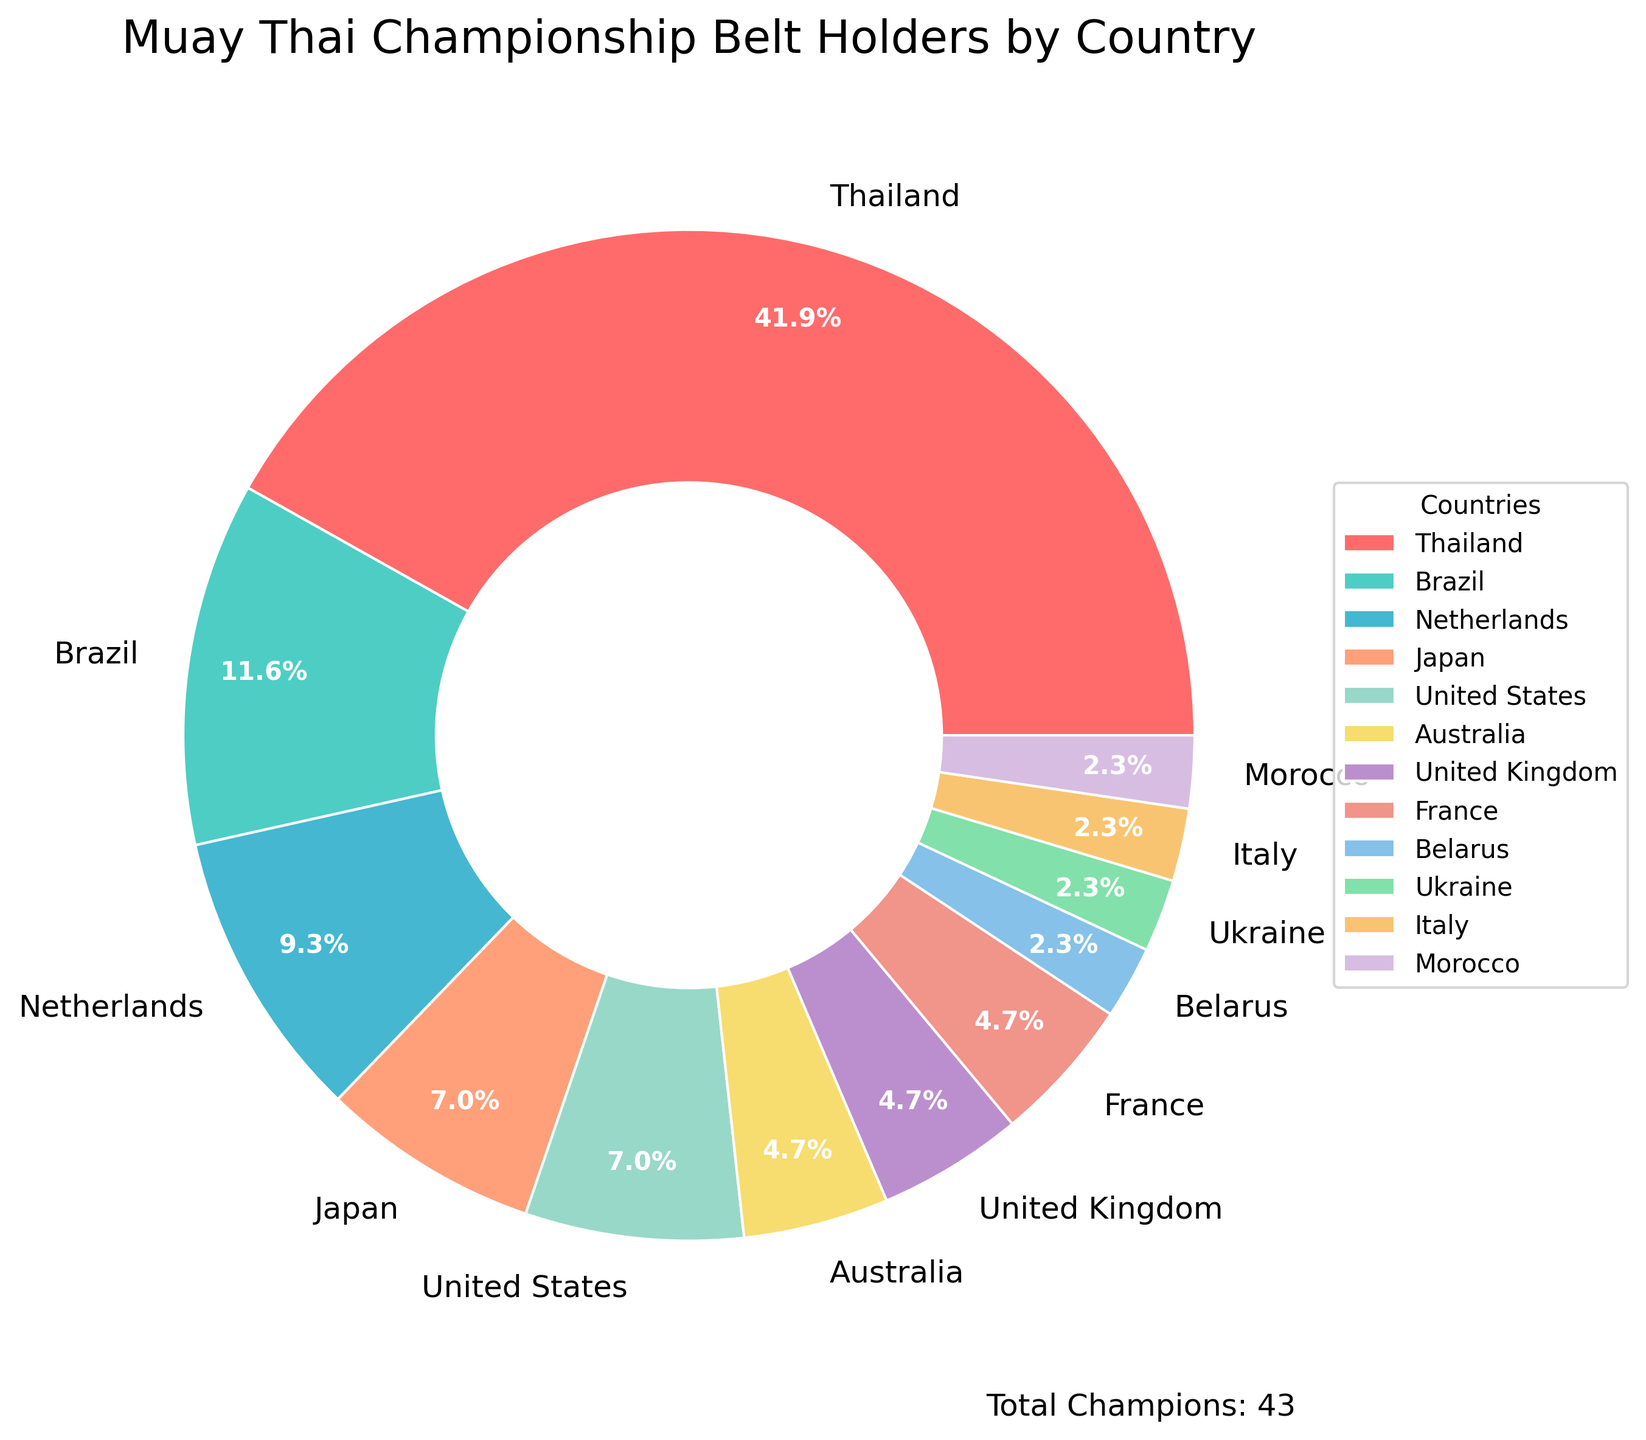Which country has the most Muay Thai championship belt holders? The figure shows that Thailand has the largest portion of the pie chart. By checking the labels, it is clear that Thailand has the highest number of champions.
Answer: Thailand How many total Muay Thai champions do the top three countries have combined? The top three countries by number of champions are Thailand (18), Brazil (5), and the Netherlands (4). Summing these values gives the total: 18 + 5 + 4 = 27
Answer: 27 Which countries have an equal number of Muay Thai champions? According to the figure, Japan and the United States both have 3 champions. Additionally, Australia, United Kingdom, and France each have 2 champions.
Answer: Japan and the United States; Australia, United Kingdom, and France What percentage of Muay Thai champions come from Thailand? The figure shows that Thailand holds 18 champions out of a total sum of 18 + 5 + 4 + 3 + 3 + 2 + 2 + 2 + 1 + 1 + 1 + 1 = 43 champions. The percentage is (18/43) * 100% ≈ 41.9%.
Answer: 41.9% How many countries have only one Muay Thai champion? By looking at the segments with smaller percentages and labels of "1", there are four countries: Belarus, Ukraine, Italy, and Morocco.
Answer: 4 Which country has fewer Muay Thai champions, France or the Netherlands? Referring to the pie chart, the Netherlands has 4 champions, whereas France has 2 champions. Therefore, France has fewer champions.
Answer: France If we grouped all countries that have 3 or fewer champions together, what percentage of the total would they represent? The countries with 3 or fewer champions are Brazil (5), Japan (3), United States (3), Australia (2), United Kingdom (2), France (2), Belarus (1), Ukraine (1), Italy (1), and Morocco (1). Summing the champions gives: 5 + 3 + 3 + 2 + 2 + 2 + 1 + 1 + 1 + 1 = 21. The percentage is (21/43) * 100% ≈ 48.8%.
Answer: 48.8% What is the total number of Muay Thai championship belt holders represented in the figure? By summing up all the champions from each country listed in the chart data: 18 + 5 + 4 + 3 + 3 + 2 + 2 + 2 + 1 + 1 + 1 + 1 = 43.
Answer: 43 Which color is used to represent the United States on the pie chart? By referring to the visual attributes of the pie chart, the segment representing the United States would be identified by its associated distinctive color within the chart.
Answer: [the specific color seen in the chart] How many more champions does Thailand have compared to Brazil? According to the chart, Thailand has 18 champions while Brazil has 5. The difference is 18 - 5 = 13.
Answer: 13 